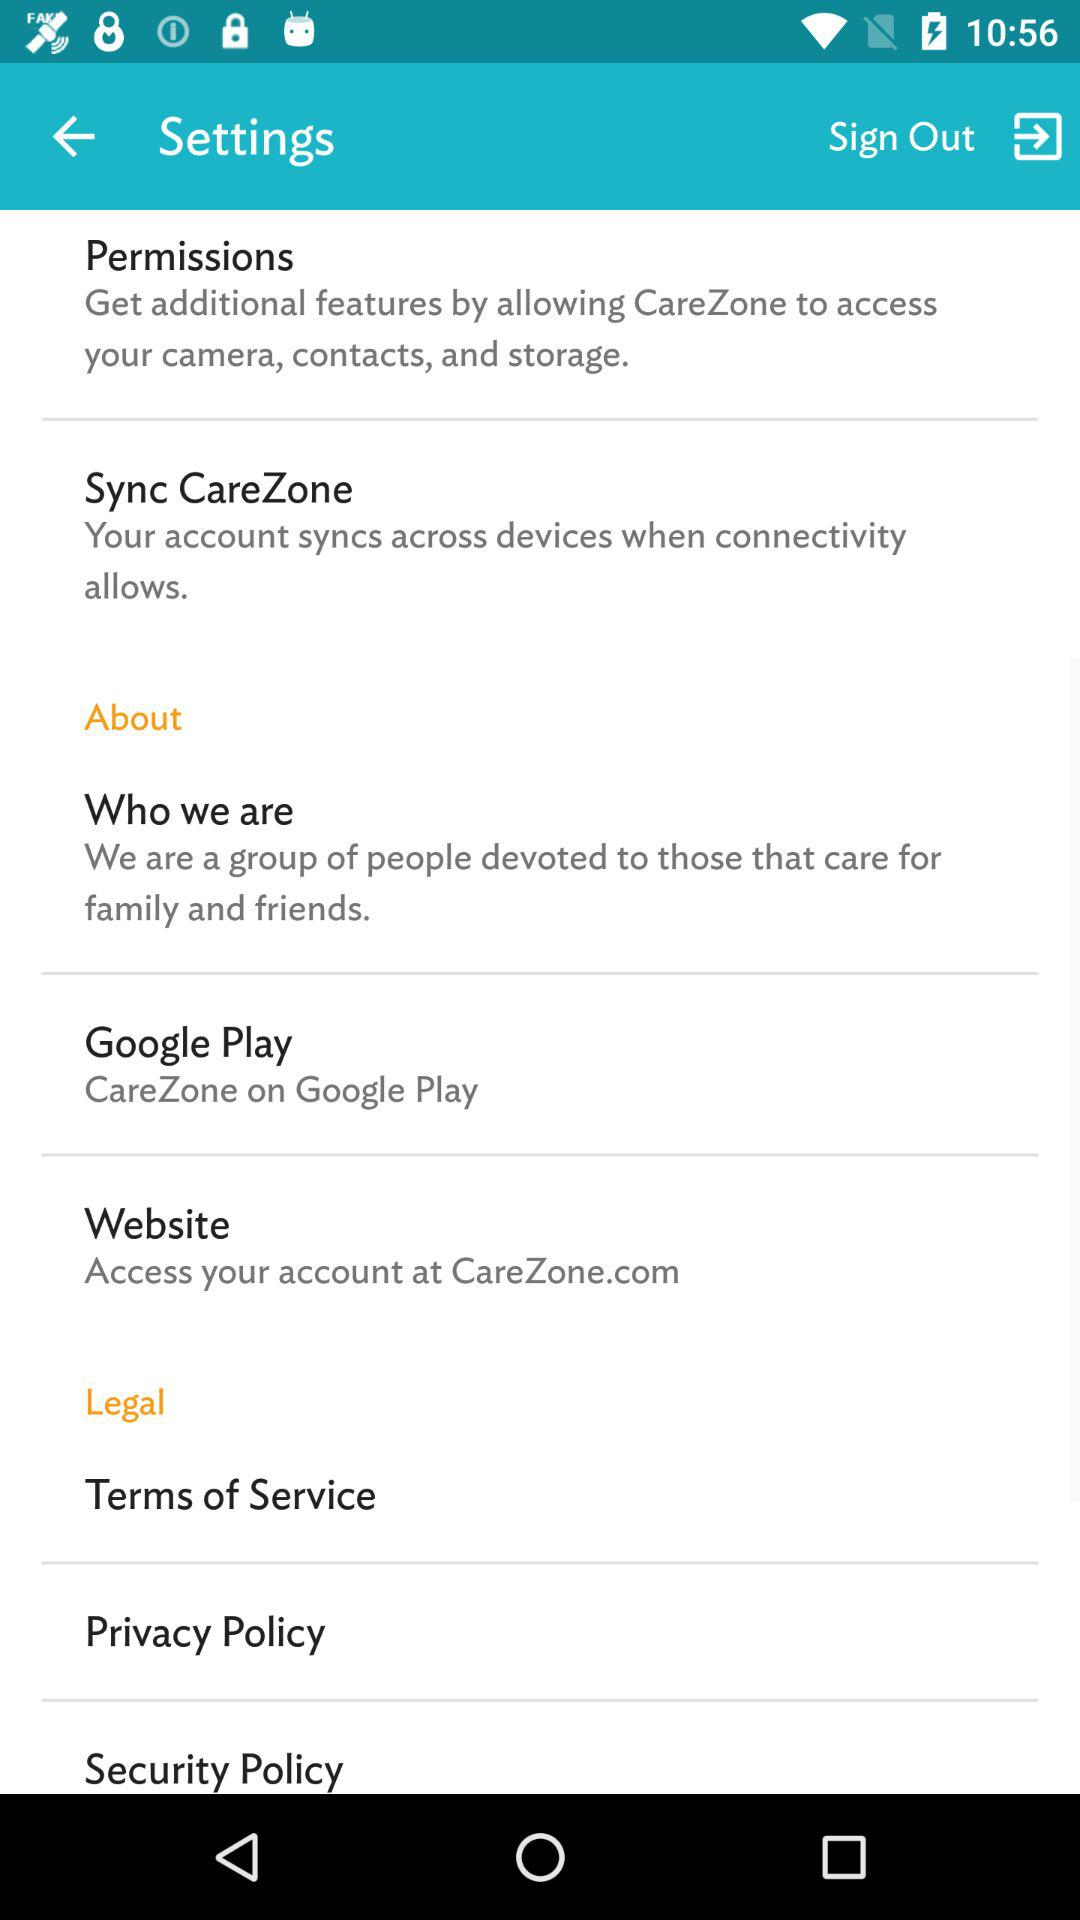What application is asking for permission? The application asking for permission is "CareZone". 